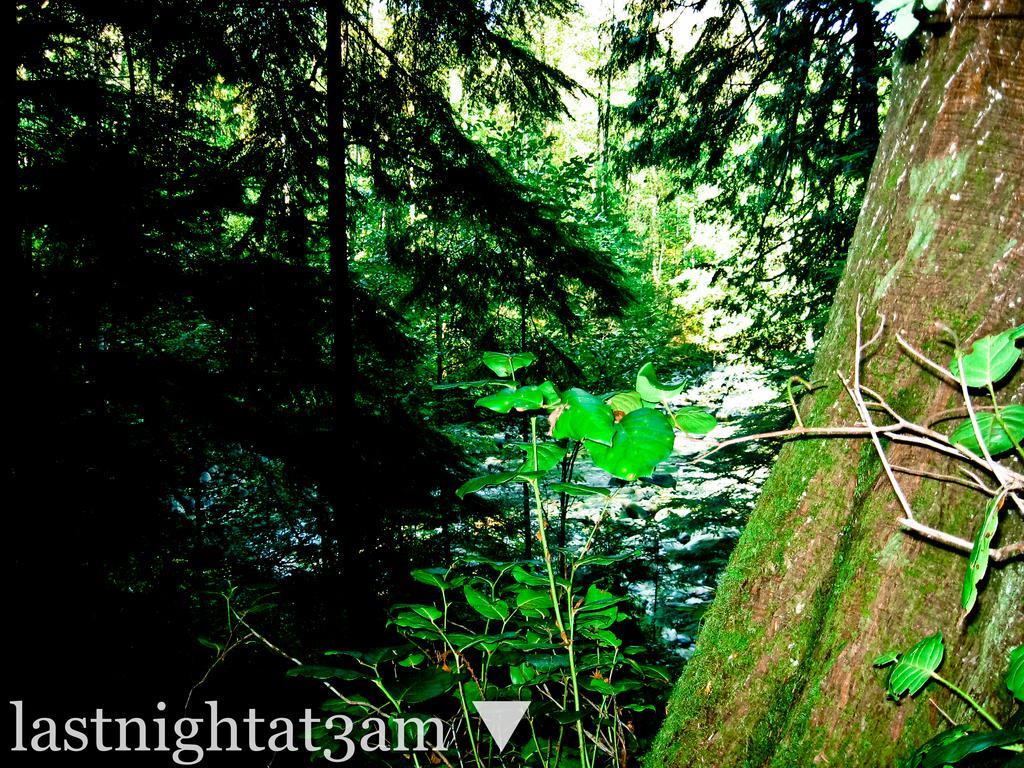How would you summarize this image in a sentence or two? In this image there are trees, on the bottom left there is some text. 